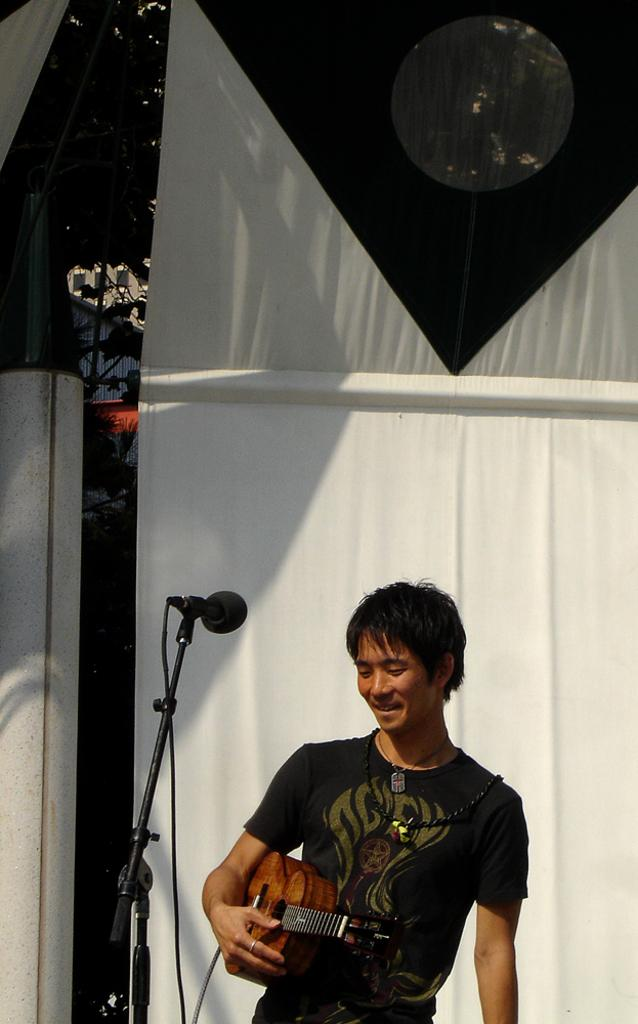What is the person in the image doing? The person is playing a guitar. What object is present in the image that is commonly used for amplifying sound? There is a microphone in the image. What type of cork can be seen in the image? There is no cork present in the image. On what stage is the person playing the guitar? The image does not show a stage; it only shows the person playing the guitar and the microphone. 